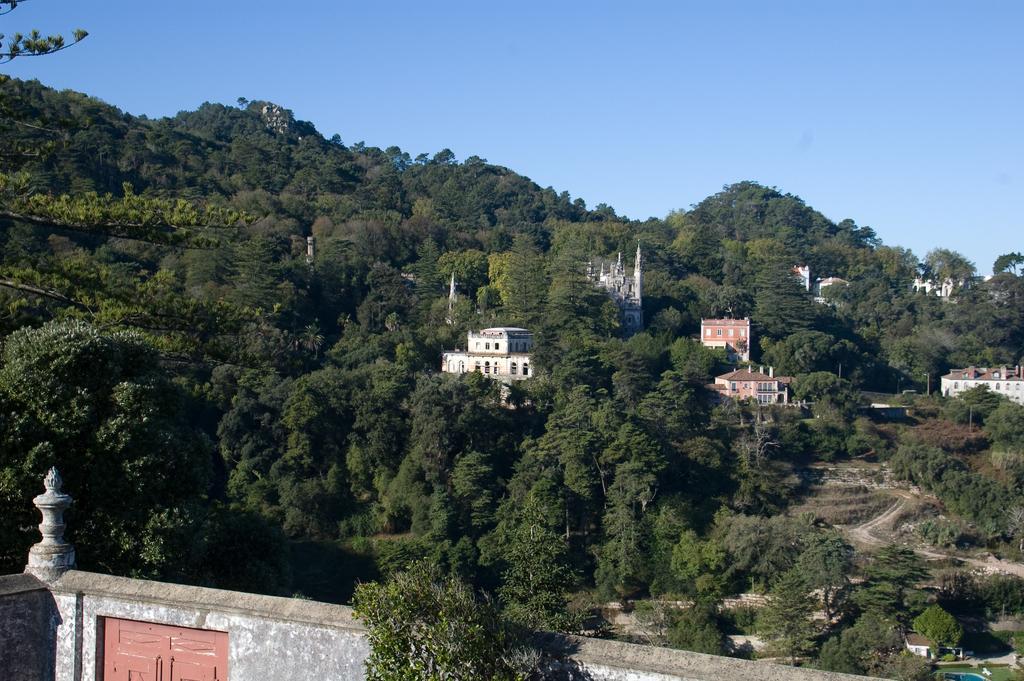How would you summarize this image in a sentence or two? In this image we can see there are so many trees and buildings, also we can see the wall with doors, in the background we can see the sky. 